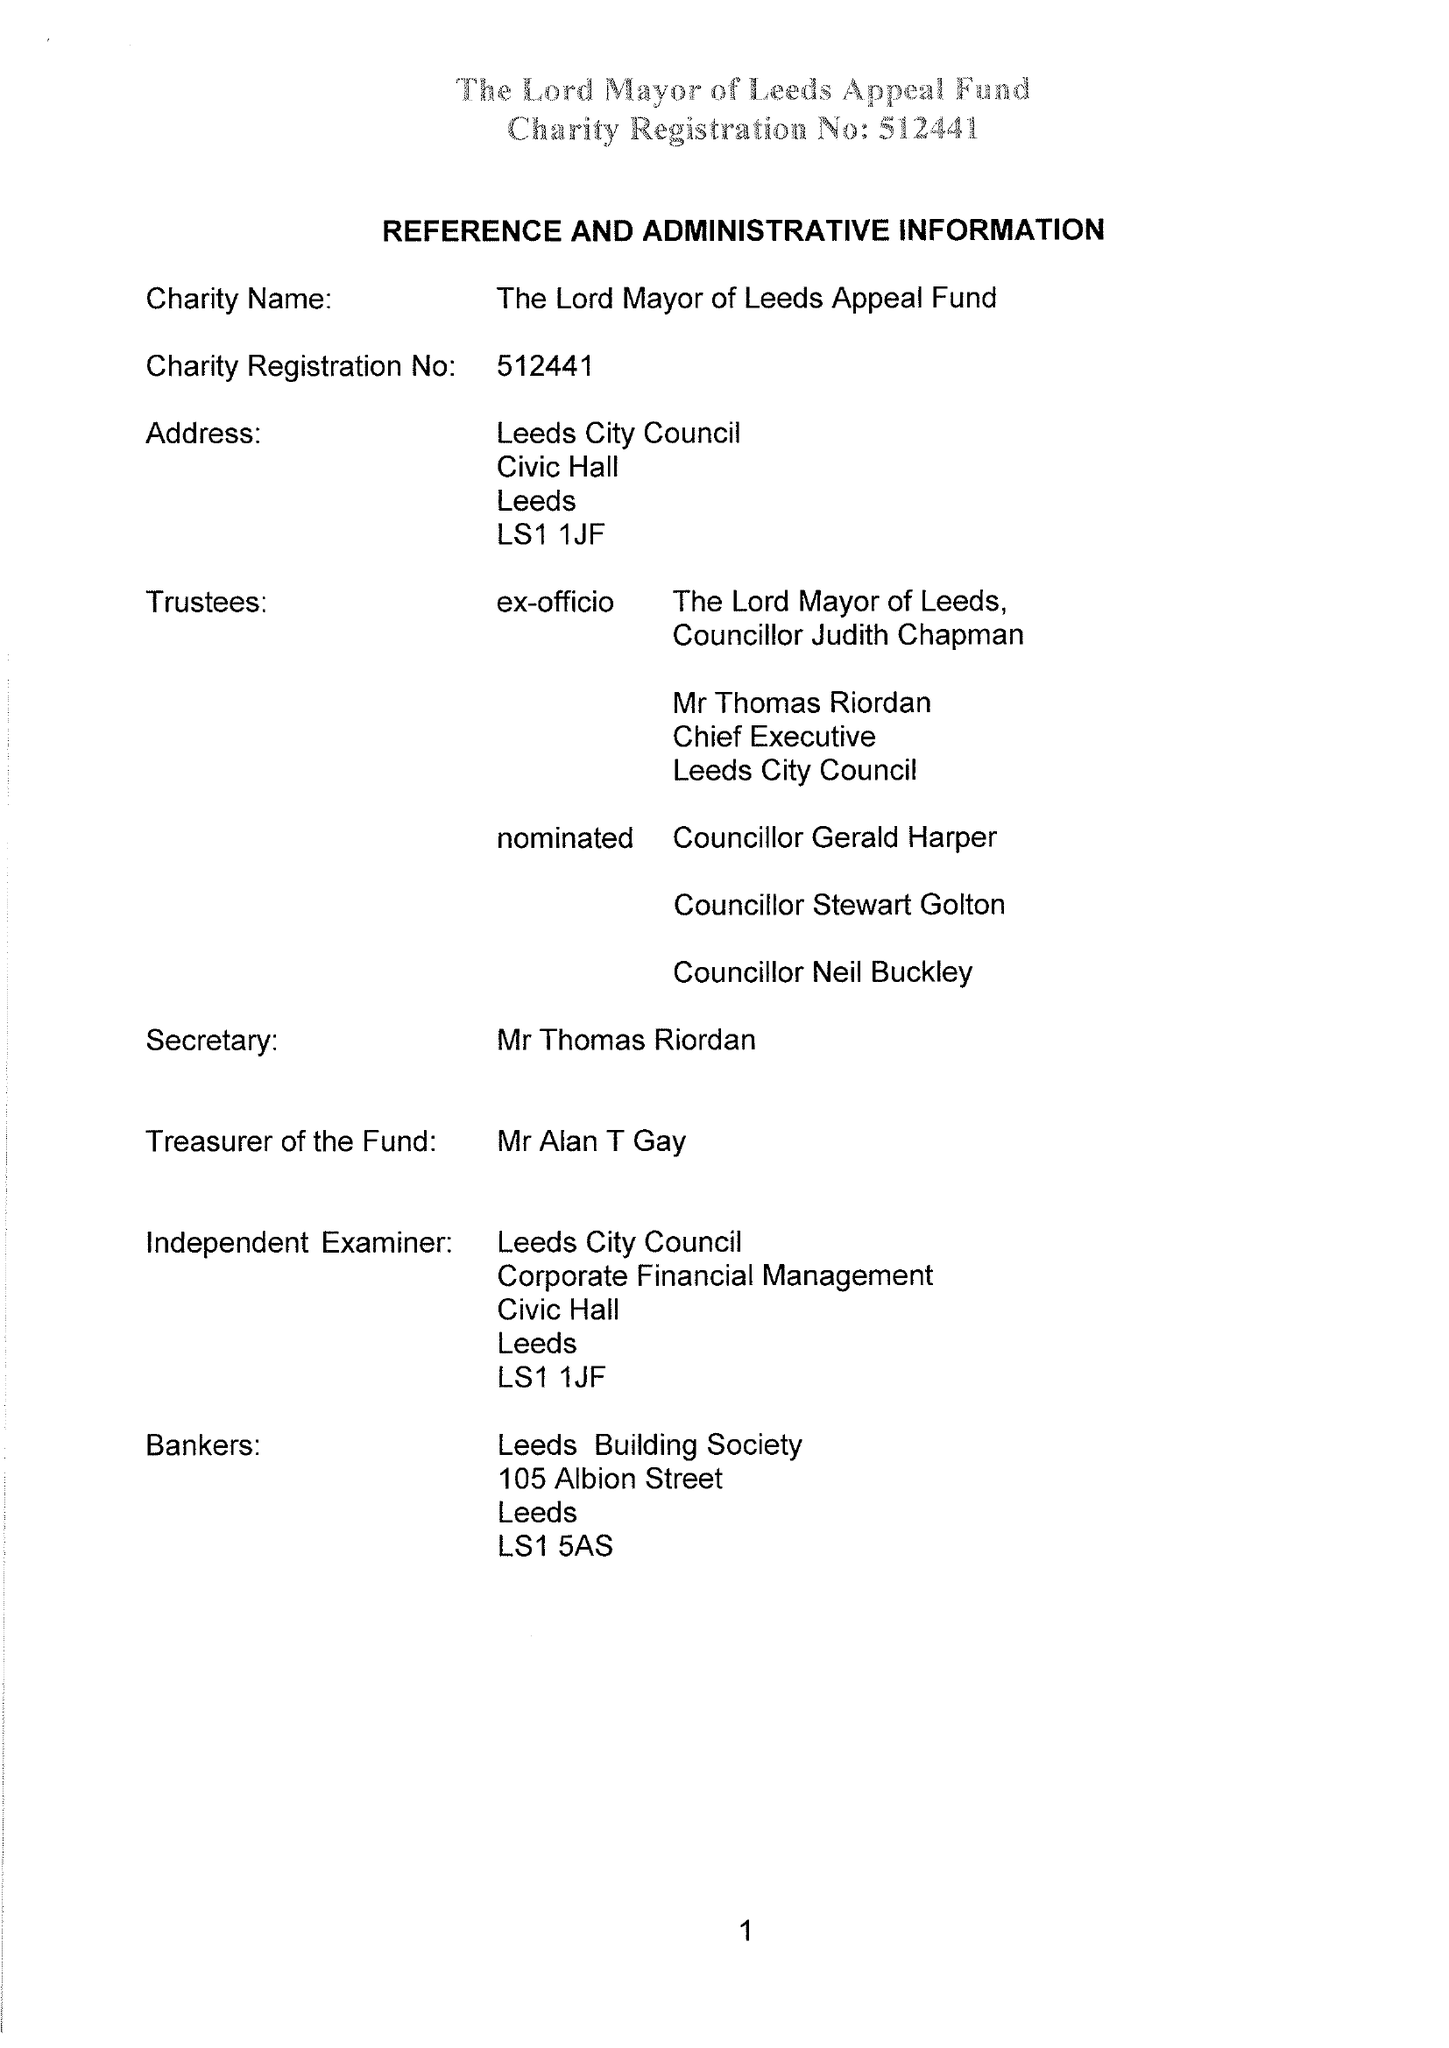What is the value for the address__post_town?
Answer the question using a single word or phrase. LEEDS 